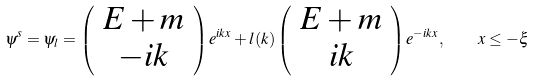<formula> <loc_0><loc_0><loc_500><loc_500>\psi ^ { s } = \psi _ { l } = \left ( \begin{array} { c } { E + m } \\ { - i k } \end{array} \right ) e ^ { i k x } + l ( k ) \left ( \begin{array} { c } { E + m } \\ { i k } \end{array} \right ) e ^ { - i k x } , \quad x \leq - \xi</formula> 